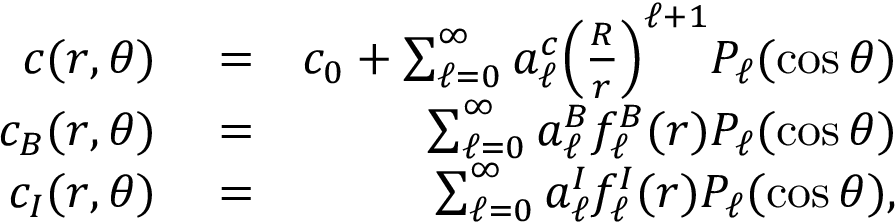Convert formula to latex. <formula><loc_0><loc_0><loc_500><loc_500>\begin{array} { r l r } { c ( r , \theta ) } & = } & { c _ { 0 } + \sum _ { \ell = 0 } ^ { \infty } a _ { \ell } ^ { c } \left ( \frac { R } { r } \right ) ^ { \ell + 1 } P _ { \ell } ( \cos \theta ) } \\ { c _ { B } ( r , \theta ) } & = } & { \sum _ { \ell = 0 } ^ { \infty } a _ { \ell } ^ { B } f _ { \ell } ^ { B } ( r ) P _ { \ell } ( \cos \theta ) } \\ { c _ { I } ( r , \theta ) } & = } & { \sum _ { \ell = 0 } ^ { \infty } a _ { \ell } ^ { I } f _ { \ell } ^ { I } ( r ) P _ { \ell } ( \cos \theta ) , } \end{array}</formula> 